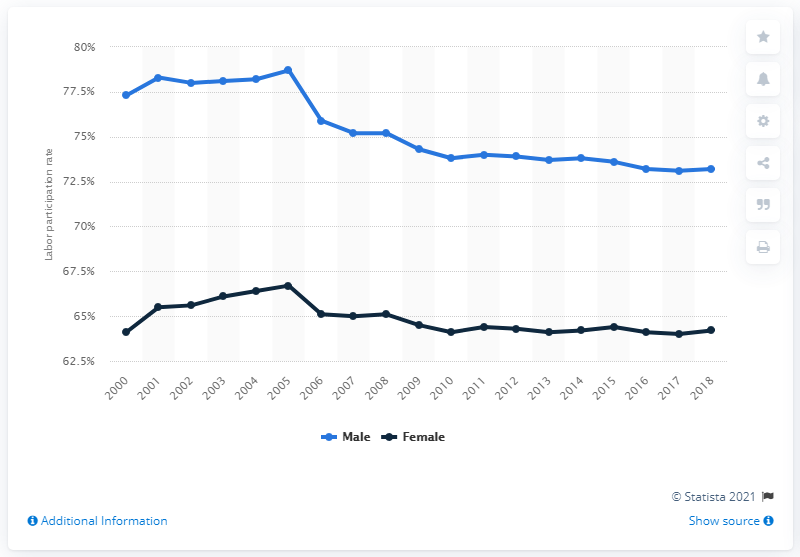List a handful of essential elements in this visual. In 2018, females comprised 64.2% of Canada's workforce. 